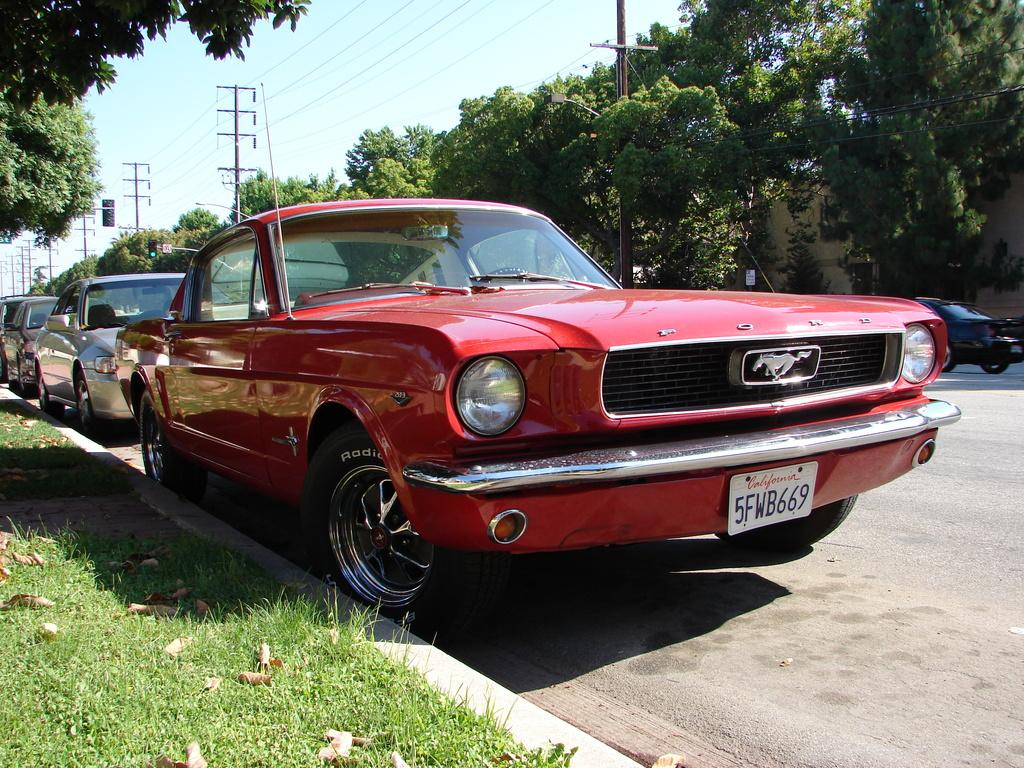Where was the image taken? The image was clicked outside. What can be seen in the middle of the image? There are cars, including a red car, and trees in the middle of the image. What is visible at the top of the image? The sky is visible at the top of the image. What type of fowl can be seen sitting on the beam in the image? There is no fowl or beam present in the image. 